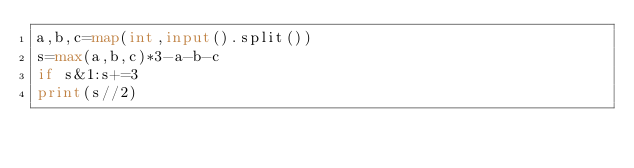Convert code to text. <code><loc_0><loc_0><loc_500><loc_500><_Python_>a,b,c=map(int,input().split())
s=max(a,b,c)*3-a-b-c
if s&1:s+=3
print(s//2)</code> 